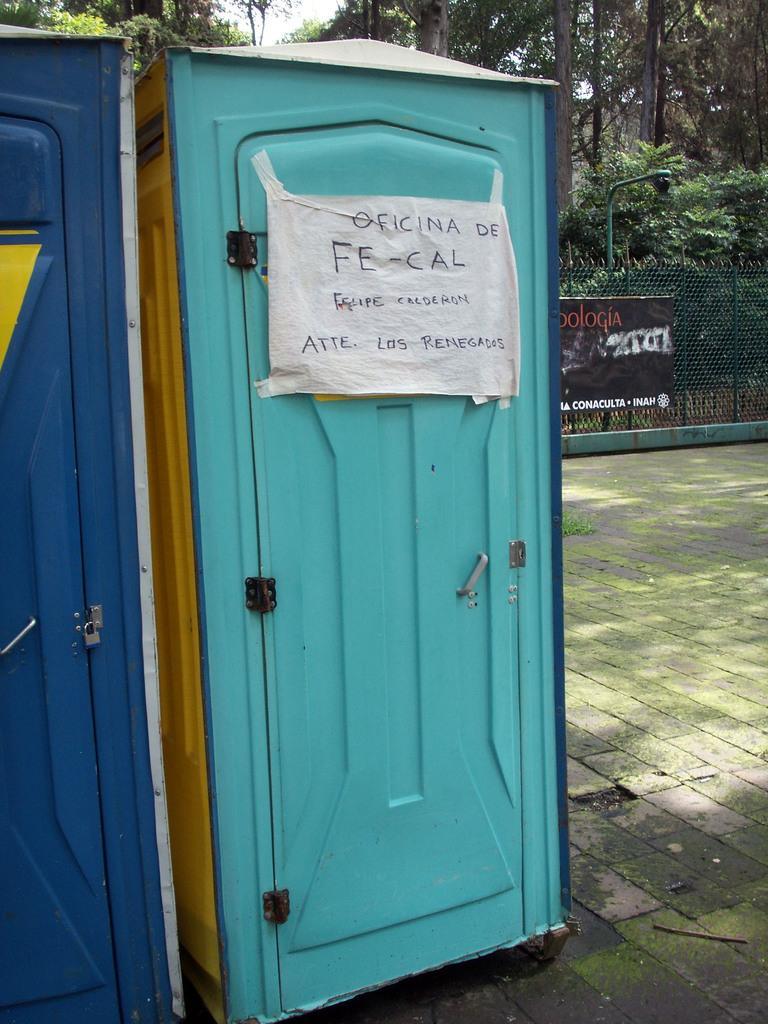What type of structures are present in the image? There are portable rooms in the image. What natural elements can be seen in the image? There are trees in the image. What type of material is visible in the image? There is mesh visible in the image. What surface is the portable room placed on? There is a floor in the image. What type of produce is being traded in the image? There is no produce or trade activity present in the image. How many balls can be seen in the image? There are no balls visible in the image. 